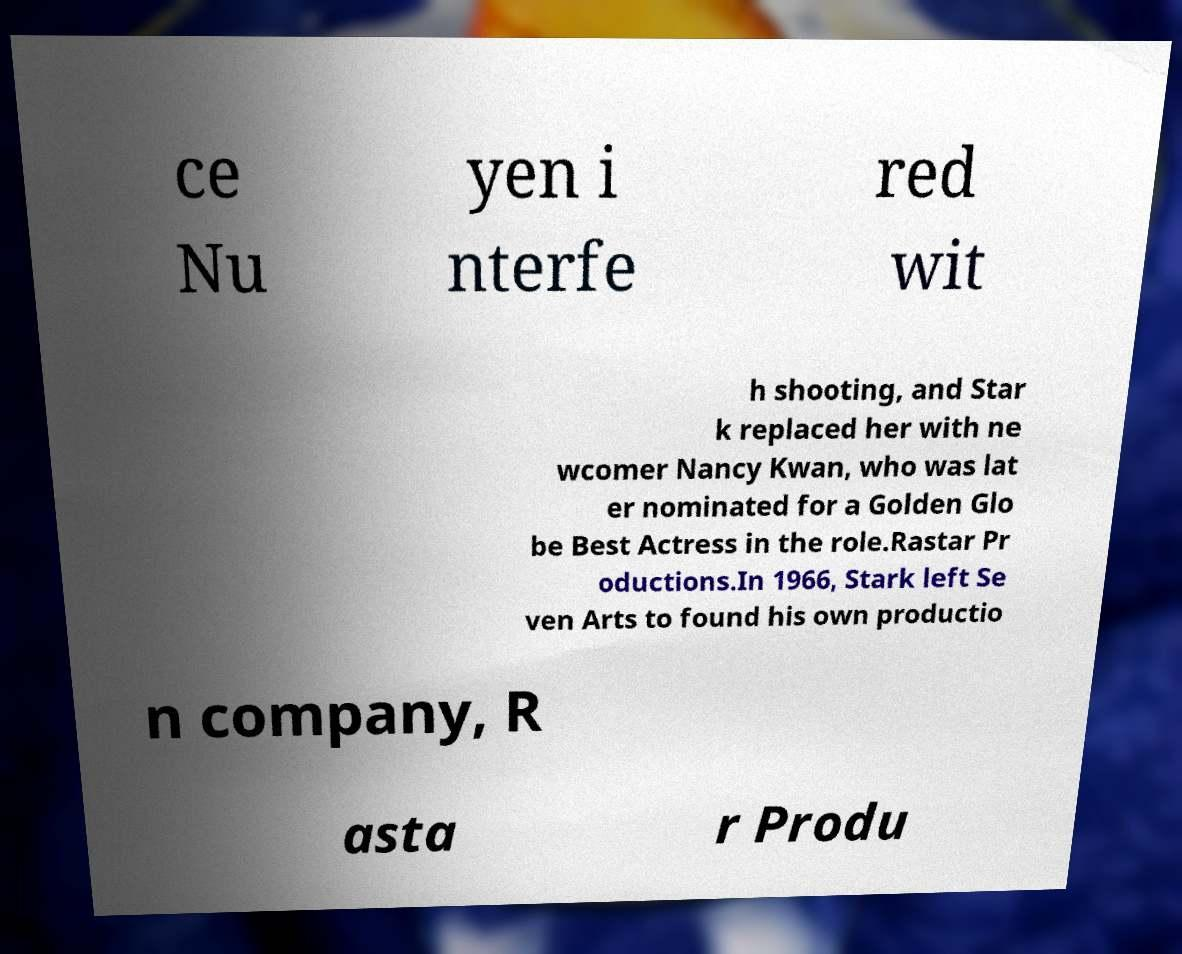Please identify and transcribe the text found in this image. ce Nu yen i nterfe red wit h shooting, and Star k replaced her with ne wcomer Nancy Kwan, who was lat er nominated for a Golden Glo be Best Actress in the role.Rastar Pr oductions.In 1966, Stark left Se ven Arts to found his own productio n company, R asta r Produ 